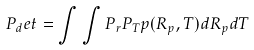Convert formula to latex. <formula><loc_0><loc_0><loc_500><loc_500>P _ { d } e t = \int \int P _ { r } P _ { T } p ( R _ { p } , T ) d R _ { p } d T</formula> 